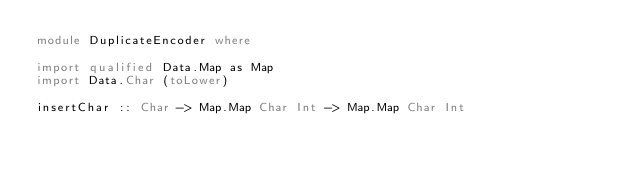<code> <loc_0><loc_0><loc_500><loc_500><_Haskell_>module DuplicateEncoder where

import qualified Data.Map as Map
import Data.Char (toLower)

insertChar :: Char -> Map.Map Char Int -> Map.Map Char Int</code> 